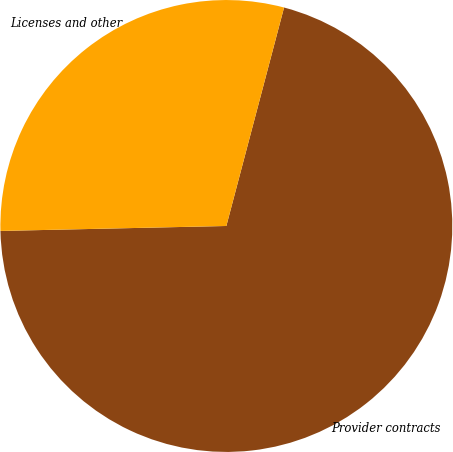Convert chart. <chart><loc_0><loc_0><loc_500><loc_500><pie_chart><fcel>Provider contracts<fcel>Licenses and other<nl><fcel>70.54%<fcel>29.46%<nl></chart> 